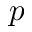Convert formula to latex. <formula><loc_0><loc_0><loc_500><loc_500>p</formula> 